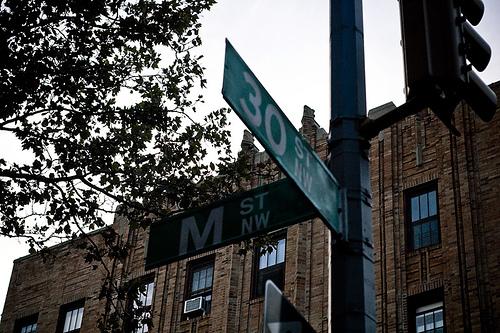Is it sunny outside?
Quick response, please. No. What is one of the streets called?
Give a very brief answer. 30 st. What does this sign mean?
Give a very brief answer. 30th st. How many windows can you see?
Short answer required. 7. Is the building made of bricks?
Write a very short answer. Yes. 